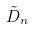<formula> <loc_0><loc_0><loc_500><loc_500>\tilde { D } _ { n }</formula> 